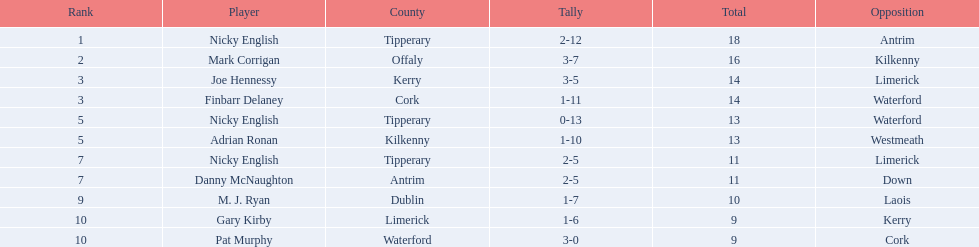Among the following players, who were placed in the bottom 5? Nicky English, Danny McNaughton, M. J. Ryan, Gary Kirby, Pat Murphy. Of them, whose counts were not 2-5? M. J. Ryan, Gary Kirby, Pat Murphy. From the previously mentioned three, which individual achieved more than 9 aggregate points? M. J. Ryan. What are the values present in the total column? 18, 16, 14, 14, 13, 13, 11, 11, 10, 9, 9. Which row has the total column displaying the number 10? 9, M. J. Ryan, Dublin, 1-7, 10, Laois. What is the name of the player in the player column corresponding to this row? M. J. Ryan. 